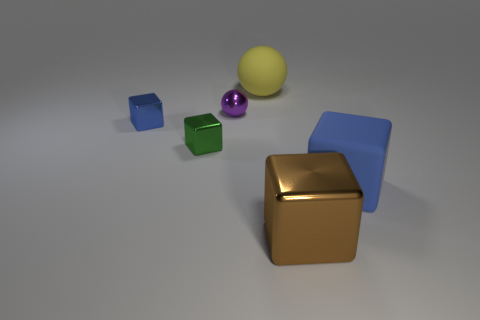How many things are yellow metallic spheres or metal things that are on the right side of the purple sphere? In the image, there is only one yellow metallic sphere, and on the right side of the purple sphere there is a metallic gold cube. So, the total count of items that fit the description of either yellow metallic spheres or metallic objects to the right of the purple sphere is two. 